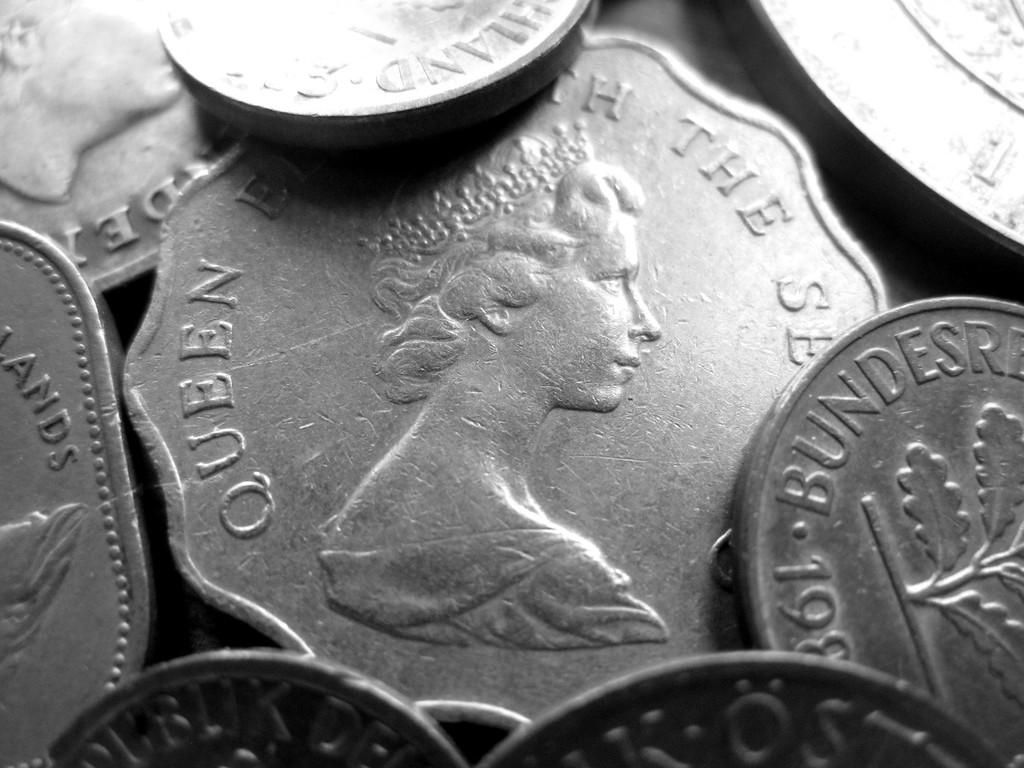<image>
Relay a brief, clear account of the picture shown. A coin featuring Queen Elizabeth the Second is centered among other silver coins. 